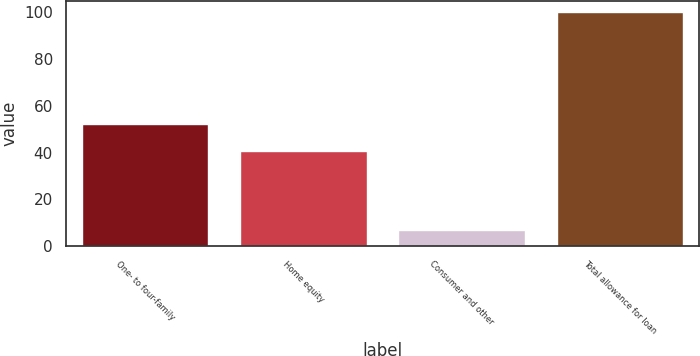Convert chart to OTSL. <chart><loc_0><loc_0><loc_500><loc_500><bar_chart><fcel>One- to four-family<fcel>Home equity<fcel>Consumer and other<fcel>Total allowance for loan<nl><fcel>52.4<fcel>40.5<fcel>7.1<fcel>100<nl></chart> 